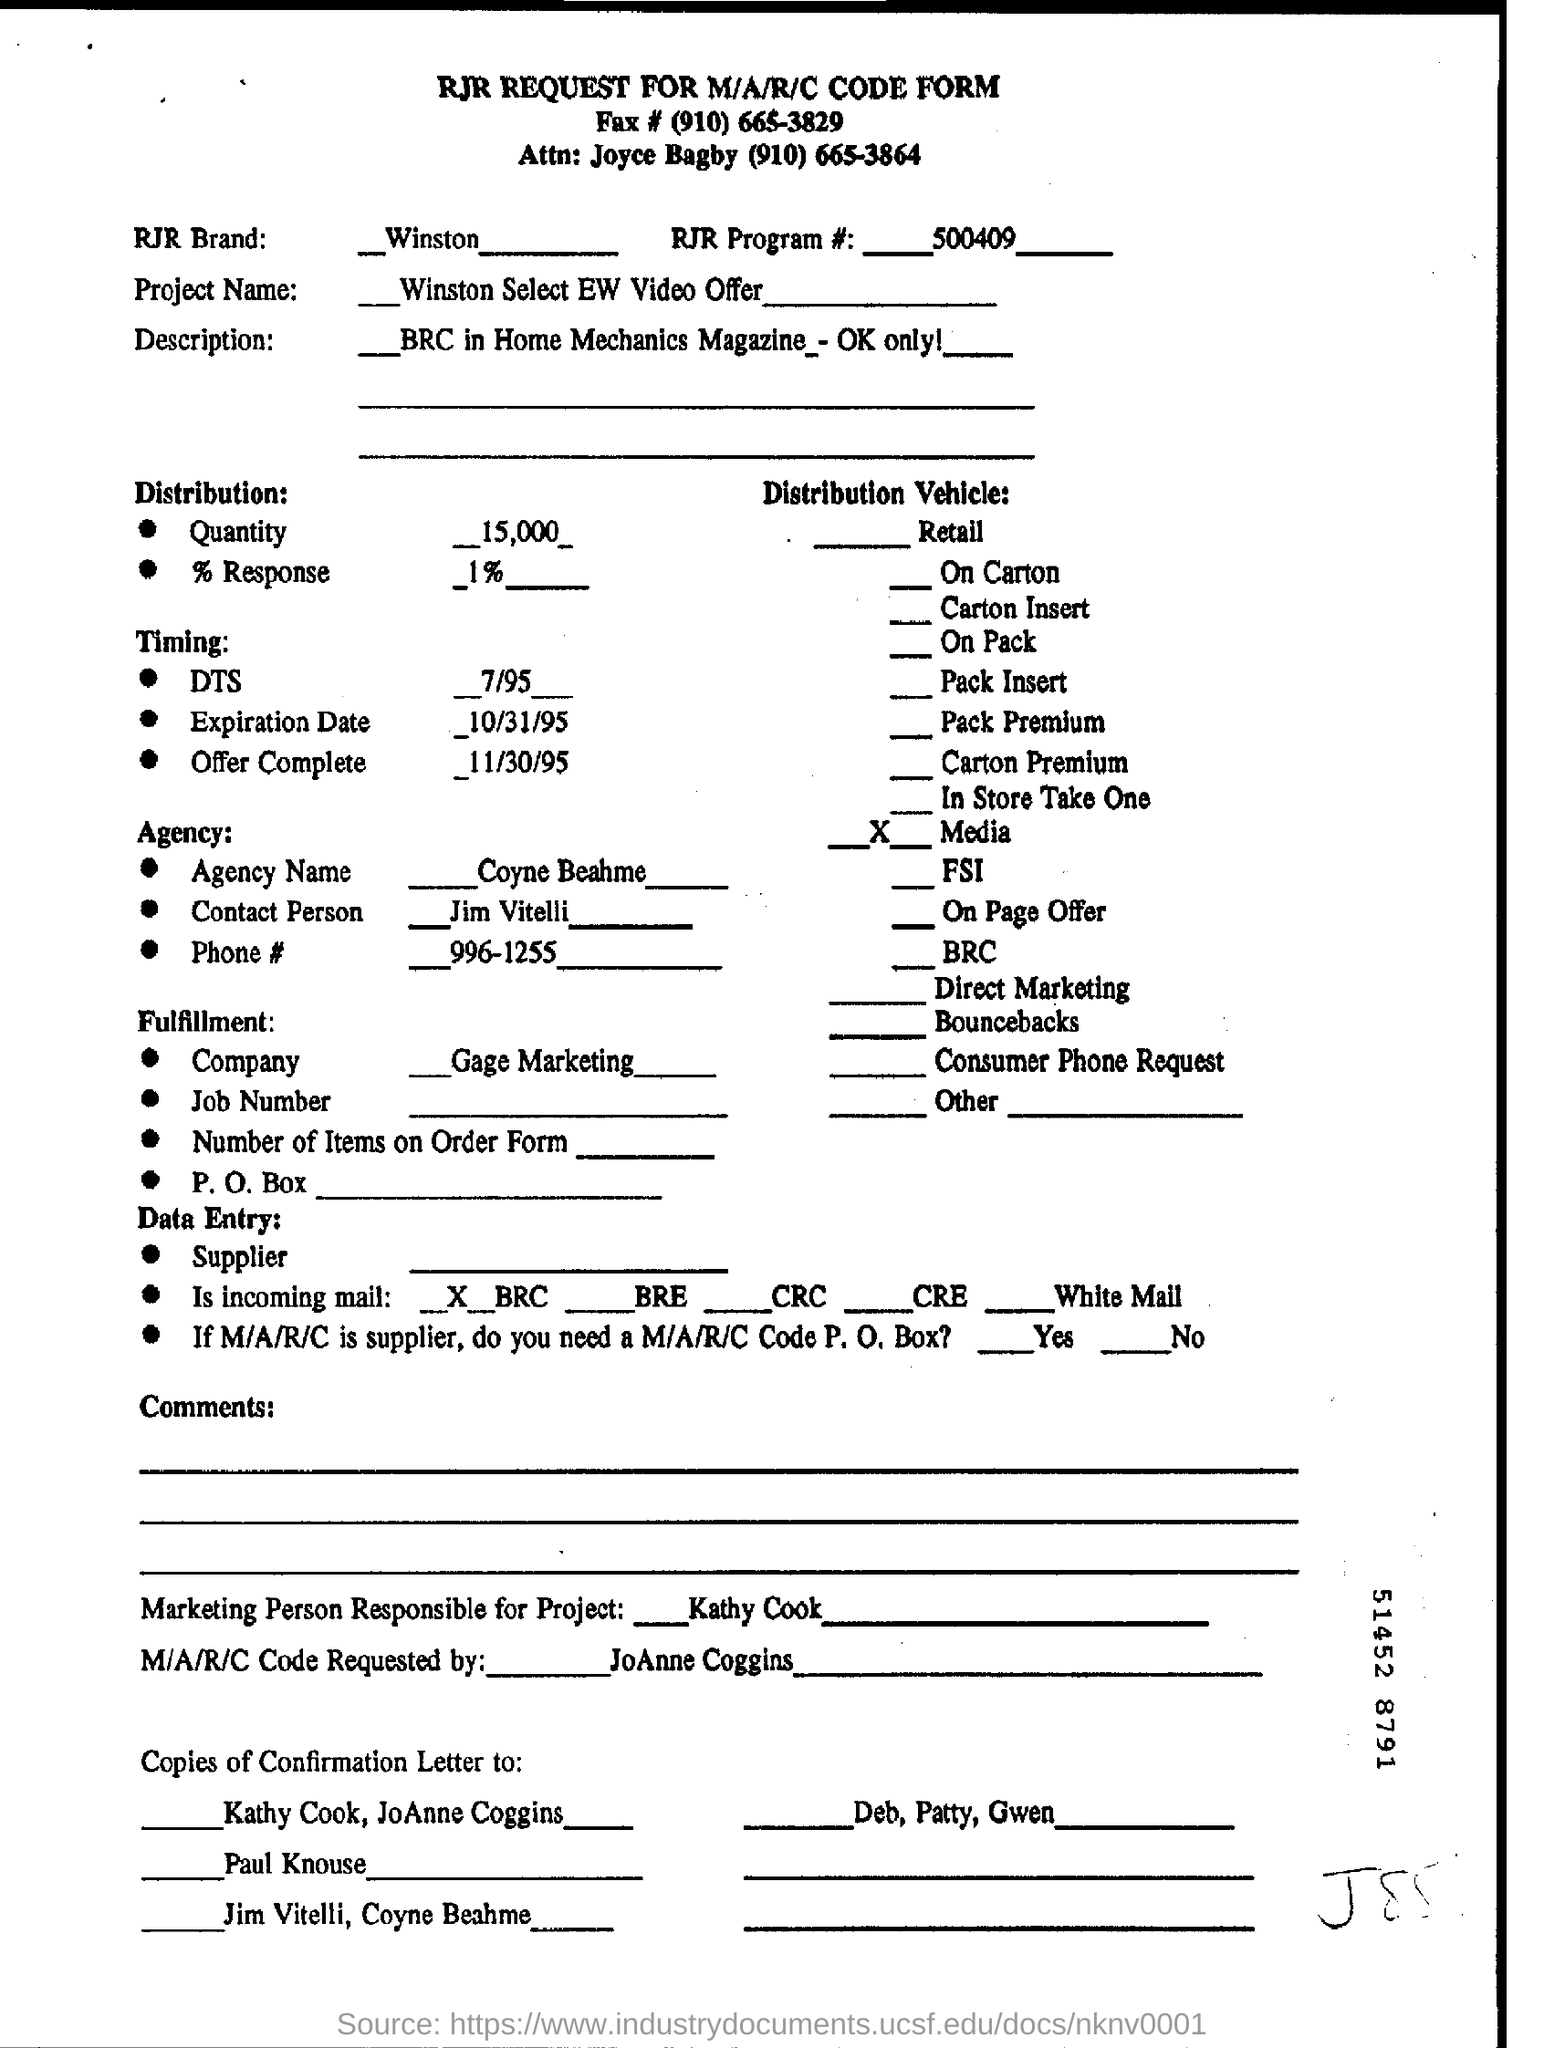Mention a couple of crucial points in this snapshot. The project name is Winston Select EW Video Offer. Kathy Cook is the marketing professional responsible for the project. The request for the M/A/R/C Code was made by JoAnne Coggins. The RJR Brand # is [a number], as designated for Winston [cigarettes]. 